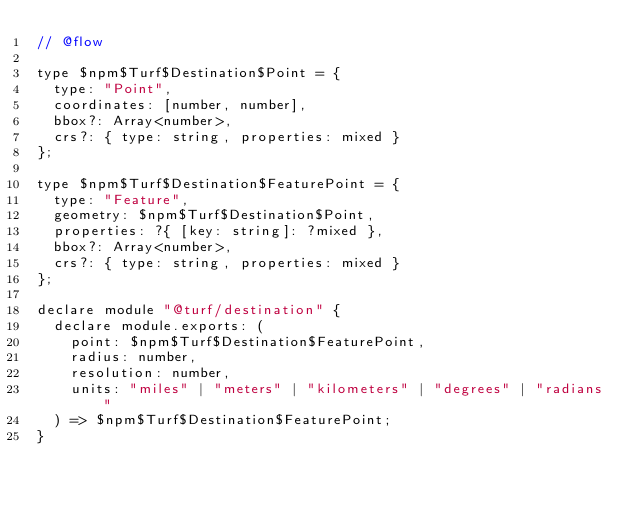Convert code to text. <code><loc_0><loc_0><loc_500><loc_500><_JavaScript_>// @flow

type $npm$Turf$Destination$Point = {
  type: "Point",
  coordinates: [number, number],
  bbox?: Array<number>,
  crs?: { type: string, properties: mixed }
};

type $npm$Turf$Destination$FeaturePoint = {
  type: "Feature",
  geometry: $npm$Turf$Destination$Point,
  properties: ?{ [key: string]: ?mixed },
  bbox?: Array<number>,
  crs?: { type: string, properties: mixed }
};

declare module "@turf/destination" {
  declare module.exports: (
    point: $npm$Turf$Destination$FeaturePoint,
    radius: number,
    resolution: number,
    units: "miles" | "meters" | "kilometers" | "degrees" | "radians"
  ) => $npm$Turf$Destination$FeaturePoint;
}
</code> 